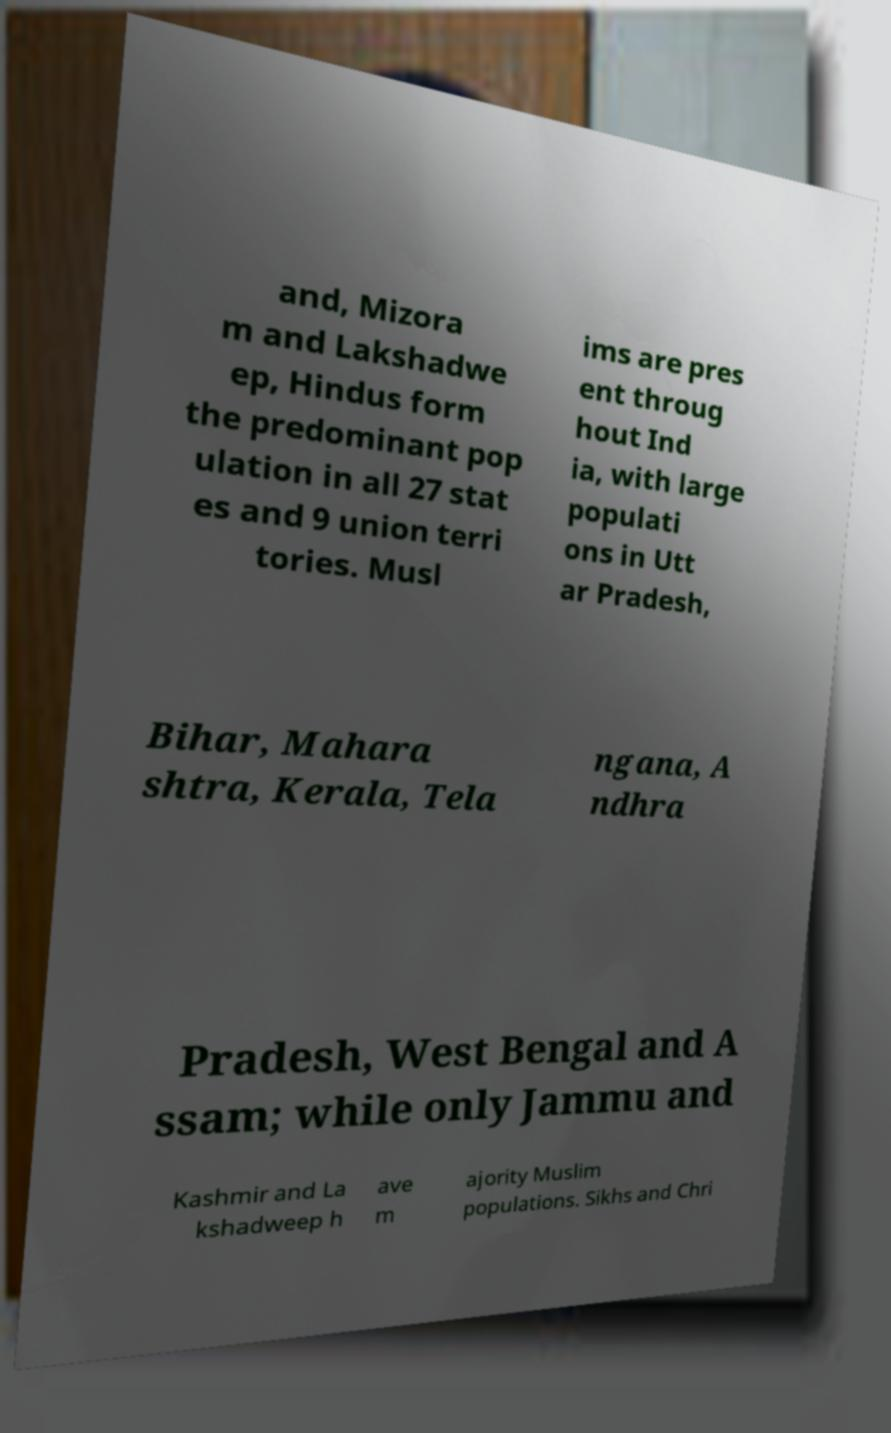Can you accurately transcribe the text from the provided image for me? and, Mizora m and Lakshadwe ep, Hindus form the predominant pop ulation in all 27 stat es and 9 union terri tories. Musl ims are pres ent throug hout Ind ia, with large populati ons in Utt ar Pradesh, Bihar, Mahara shtra, Kerala, Tela ngana, A ndhra Pradesh, West Bengal and A ssam; while only Jammu and Kashmir and La kshadweep h ave m ajority Muslim populations. Sikhs and Chri 